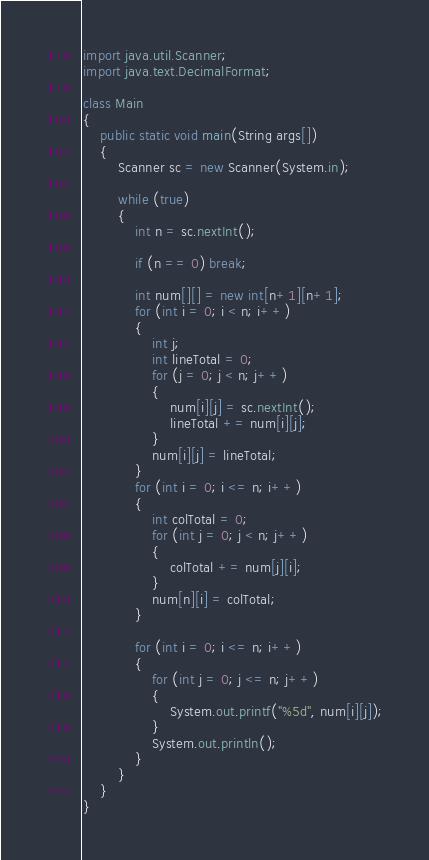Convert code to text. <code><loc_0><loc_0><loc_500><loc_500><_Java_>import java.util.Scanner;
import java.text.DecimalFormat;

class Main
{
	public static void main(String args[])
	{
		Scanner sc = new Scanner(System.in);
		
		while (true)
		{
			int n = sc.nextInt();
			
			if (n == 0) break;
			
			int num[][] = new int[n+1][n+1];
			for (int i = 0; i < n; i++)
			{
				int j;
				int lineTotal = 0;
				for (j = 0; j < n; j++)
				{
					num[i][j] = sc.nextInt();
					lineTotal += num[i][j];
				}
				num[i][j] = lineTotal;
			}
			for (int i = 0; i <= n; i++)
			{
				int colTotal = 0;
				for (int j = 0; j < n; j++)
				{
					colTotal += num[j][i];
				}
				num[n][i] = colTotal;
			}		

			for (int i = 0; i <= n; i++)
			{
				for (int j = 0; j <= n; j++)
				{
					System.out.printf("%5d", num[i][j]);
				}
				System.out.println();
			}
		}
	}
}</code> 